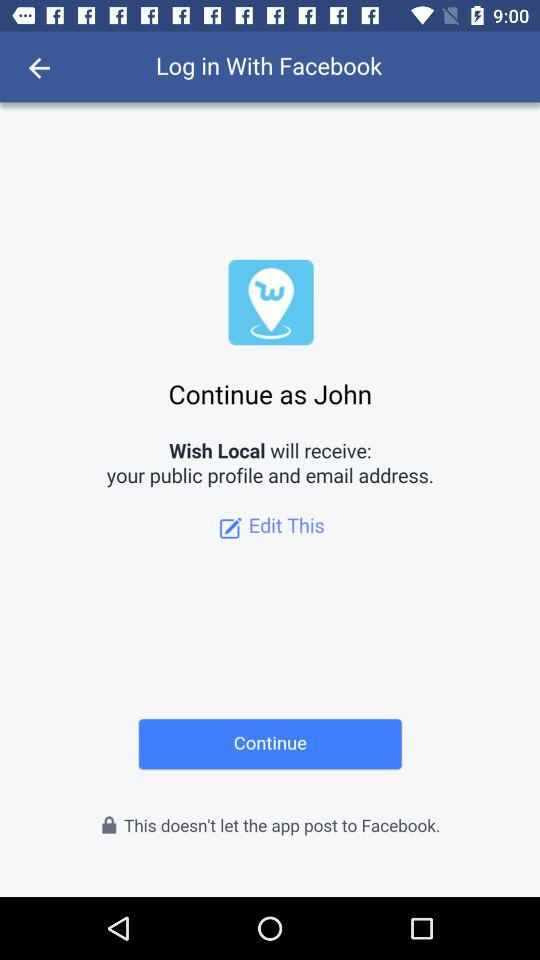What is the name of the user? The name of the user is John. 